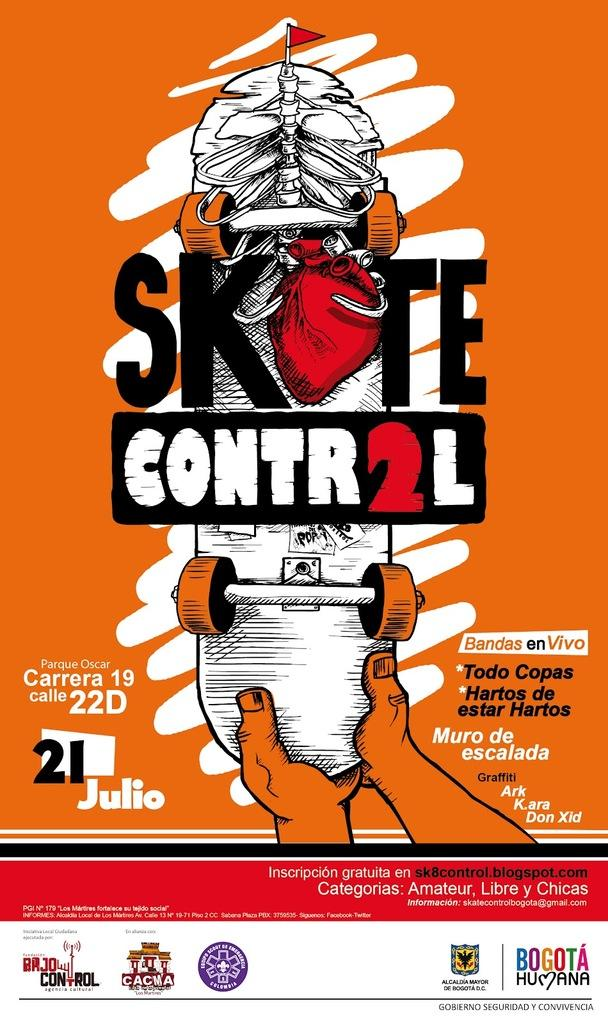Provide a one-sentence caption for the provided image. a picture of a magazine or book cover that shows the words skate control. 